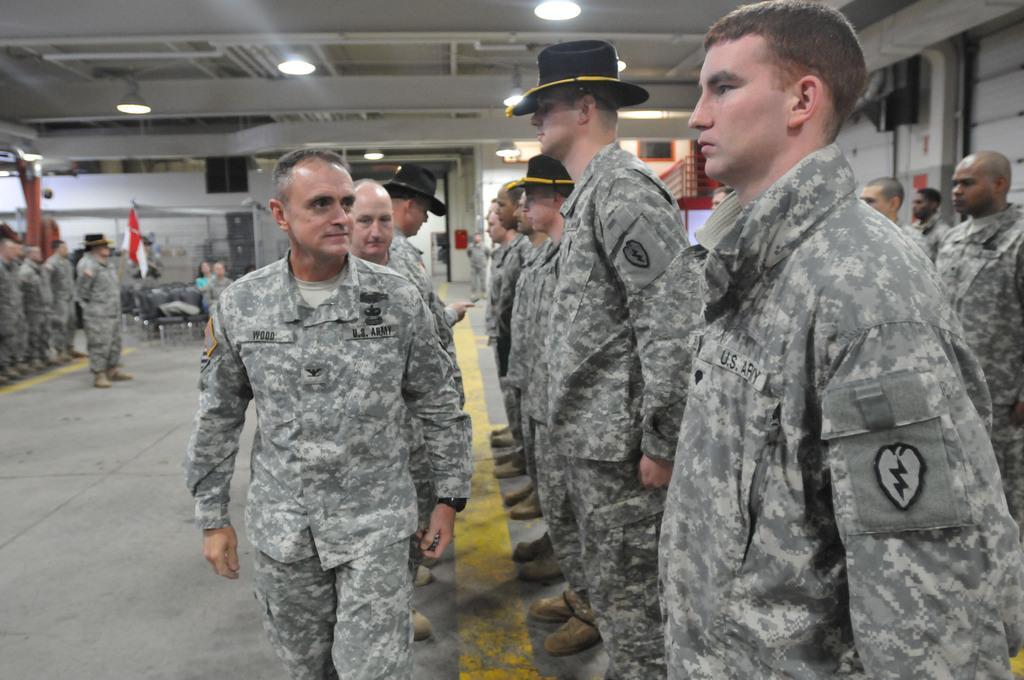How would you summarize this image in a sentence or two? Here we can see group of people on the floor. There are chairs, lights, and a flag. In the background there is a wall. 